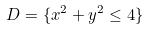Convert formula to latex. <formula><loc_0><loc_0><loc_500><loc_500>D = \{ x ^ { 2 } + y ^ { 2 } \leq 4 \}</formula> 